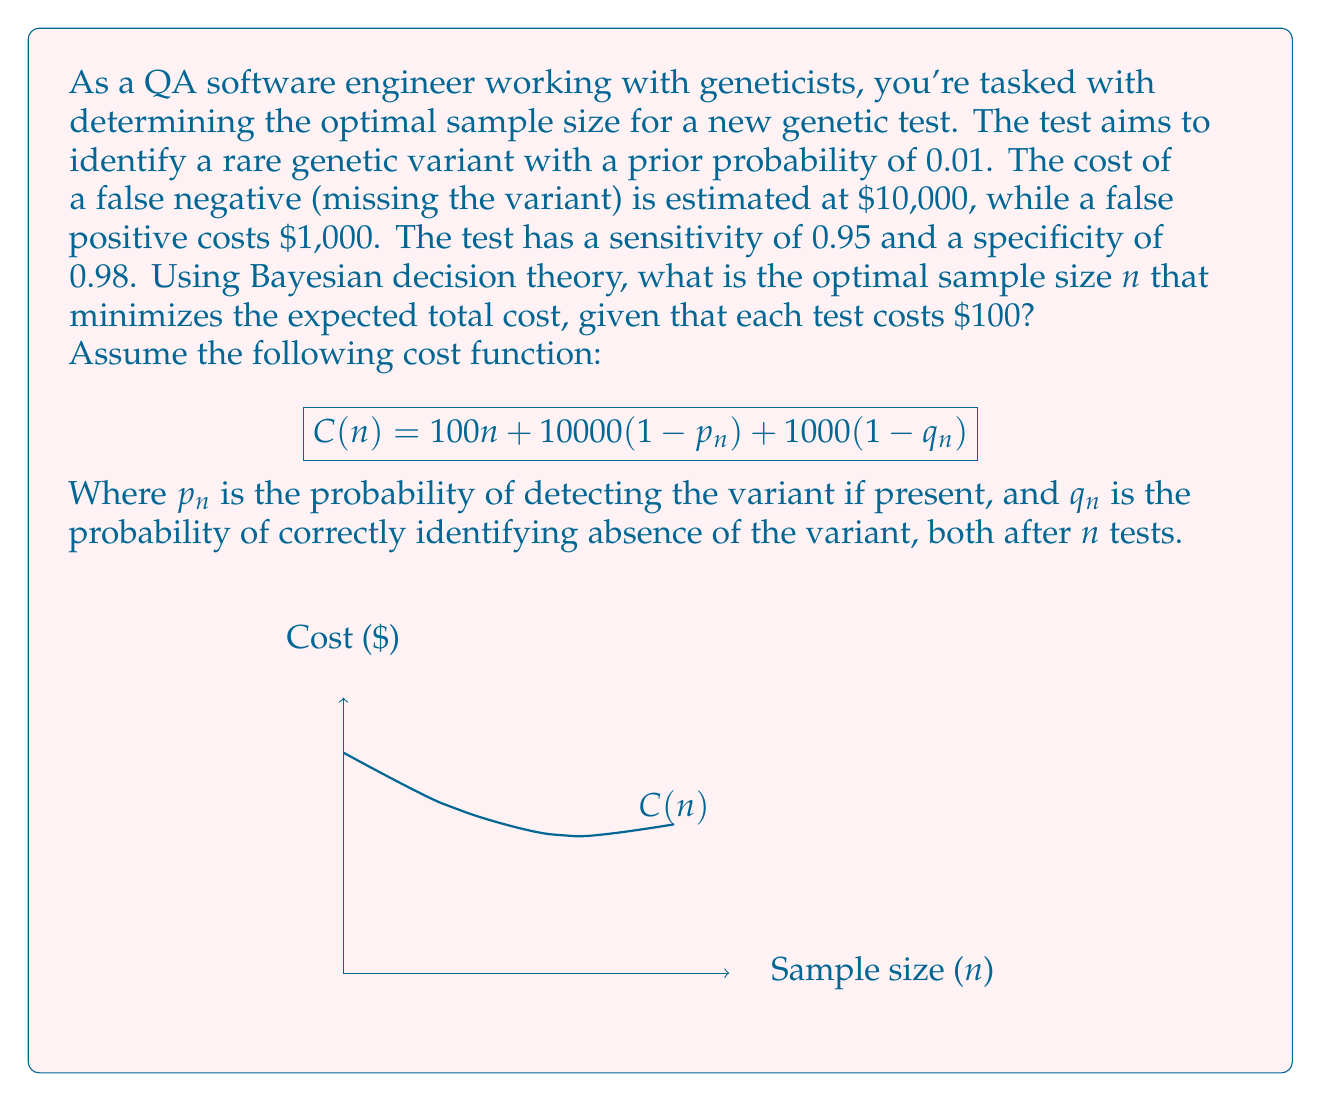Provide a solution to this math problem. To solve this problem, we'll use Bayesian decision theory and follow these steps:

1) First, let's define our variables:
   $\pi = 0.01$ (prior probability of the variant)
   $\alpha = 0.05$ (false negative rate, 1 - sensitivity)
   $\beta = 0.02$ (false positive rate, 1 - specificity)

2) We need to calculate $p_n$ and $q_n$:
   $p_n = 1 - \alpha^n = 1 - 0.05^n$
   $q_n = 1 - \beta^n = 1 - 0.02^n$

3) Now, we can write our cost function:
   $$C(n) = 100n + 10000\pi(1-p_n) + 1000(1-\pi)(1-q_n)$$

4) Substituting the values:
   $$C(n) = 100n + 100(0.05^n) + 990(0.02^n)$$

5) To find the minimum, we need to differentiate $C(n)$ with respect to $n$ and set it to zero:
   $$\frac{dC}{dn} = 100 - 5\ln(0.05)(0.05^n) - 19.8\ln(0.02)(0.02^n) = 0$$

6) This equation cannot be solved analytically. We need to use numerical methods or plotting to find the optimal $n$.

7) Using a numerical solver or plotting the function, we find that the minimum occurs at approximately $n = 2.8$.

8) Since $n$ must be a whole number, we compare $C(2)$, $C(3)$, and $C(4)$:
   $C(2) \approx 295.15$
   $C(3) \approx 294.01$
   $C(4) \approx 294.40$

9) The minimum cost occurs when $n = 3$.
Answer: 3 tests 